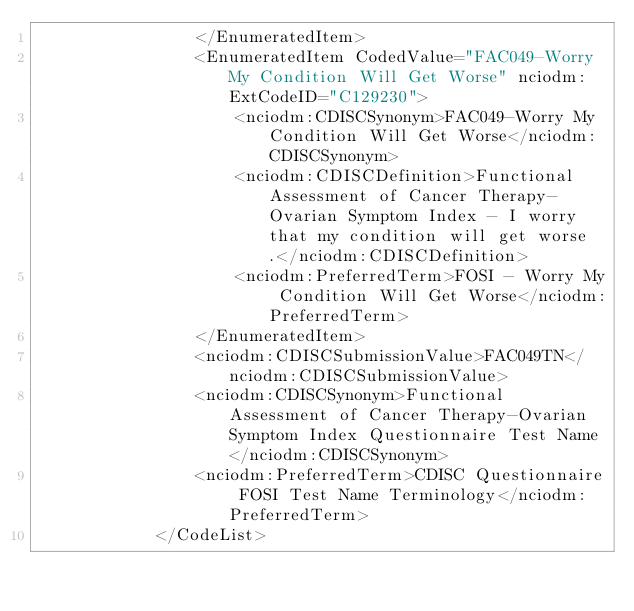Convert code to text. <code><loc_0><loc_0><loc_500><loc_500><_XML_>                </EnumeratedItem>
                <EnumeratedItem CodedValue="FAC049-Worry My Condition Will Get Worse" nciodm:ExtCodeID="C129230">
                    <nciodm:CDISCSynonym>FAC049-Worry My Condition Will Get Worse</nciodm:CDISCSynonym>
                    <nciodm:CDISCDefinition>Functional Assessment of Cancer Therapy-Ovarian Symptom Index - I worry that my condition will get worse.</nciodm:CDISCDefinition>
                    <nciodm:PreferredTerm>FOSI - Worry My Condition Will Get Worse</nciodm:PreferredTerm>
                </EnumeratedItem>
                <nciodm:CDISCSubmissionValue>FAC049TN</nciodm:CDISCSubmissionValue>
                <nciodm:CDISCSynonym>Functional Assessment of Cancer Therapy-Ovarian Symptom Index Questionnaire Test Name</nciodm:CDISCSynonym>
                <nciodm:PreferredTerm>CDISC Questionnaire FOSI Test Name Terminology</nciodm:PreferredTerm>
            </CodeList>
            
</code> 